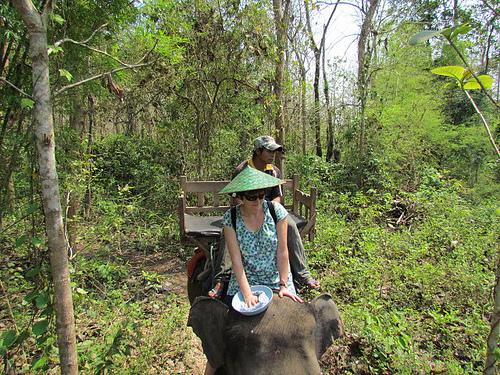Question: what is the lady riding on?
Choices:
A. A giraffe.
B. A horse.
C. A mule.
D. An elephant.
Answer with the letter. Answer: D Question: when is the lady riding the elephant?
Choices:
A. During a trip in the mountains.
B. On the weekend.
C. During a river crossing.
D. During a visit in the forest.
Answer with the letter. Answer: D Question: how comfortable is it riding an elephant?
Choices:
A. Very comfortable.
B. Very uncomfortable.
C. Extremely comfy.
D. Very pleasant.
Answer with the letter. Answer: B Question: where are they heading to?
Choices:
A. In the middle of the forest.
B. To the castle.
C. To the neighbor's house.
D. To the gym.
Answer with the letter. Answer: A 